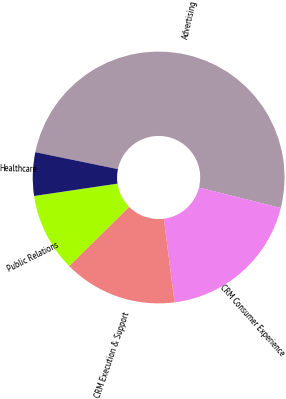<chart> <loc_0><loc_0><loc_500><loc_500><pie_chart><fcel>Advertising<fcel>CRM Consumer Experience<fcel>CRM Execution & Support<fcel>Public Relations<fcel>Healthcare<nl><fcel>50.66%<fcel>19.1%<fcel>14.59%<fcel>10.08%<fcel>5.57%<nl></chart> 